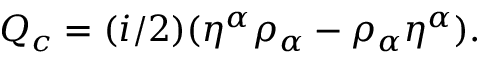Convert formula to latex. <formula><loc_0><loc_0><loc_500><loc_500>Q _ { c } = ( i / 2 ) ( { \eta } ^ { \alpha } { \rho } _ { \alpha } - { \rho } _ { \alpha } { \eta } ^ { \alpha } ) .</formula> 